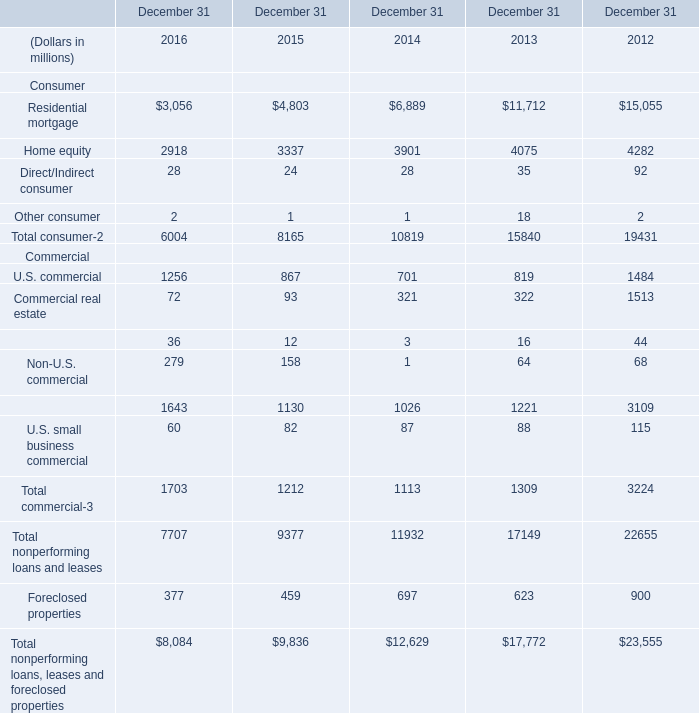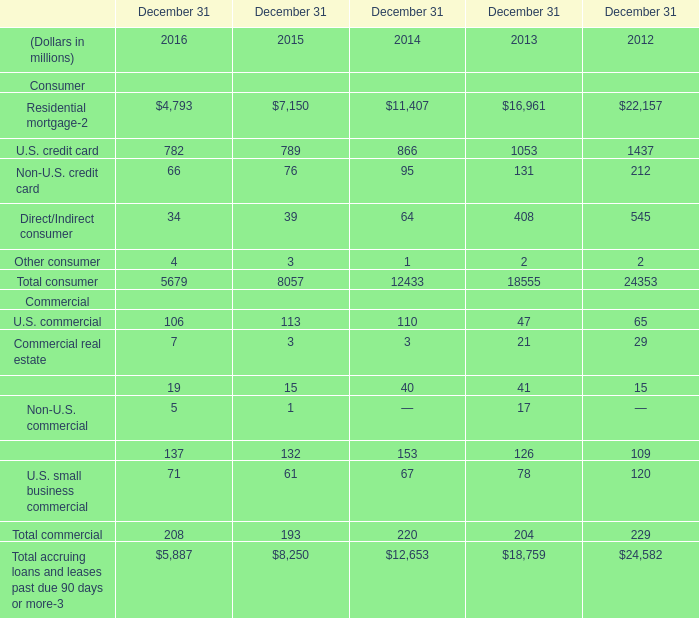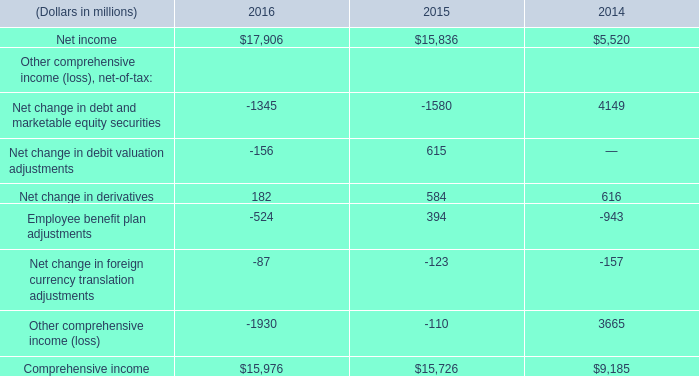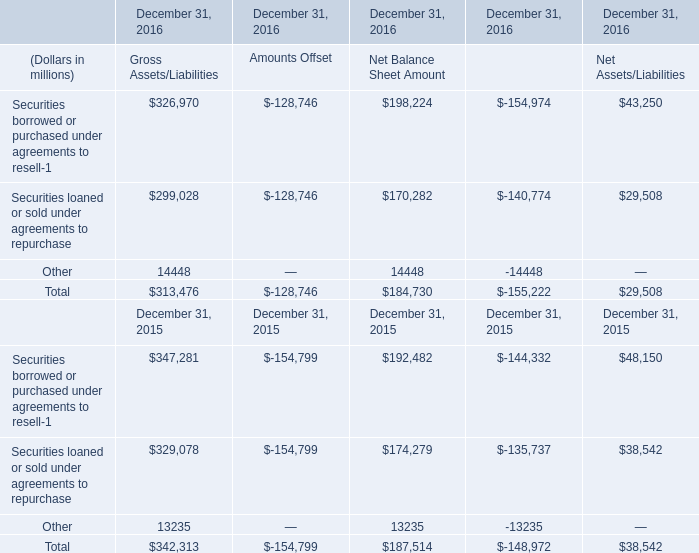What's the sum of Net income of 2015, Residential mortgage of December 31 2012, and Total nonperforming loans, leases and foreclosed properties Commercial of December 31 2012 ? 
Computations: ((15836.0 + 22157.0) + 23555.0)
Answer: 61548.0. 